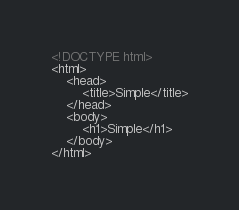<code> <loc_0><loc_0><loc_500><loc_500><_HTML_><!DOCTYPE html>
<html>
    <head>
        <title>Simple</title>
    </head>
    <body>
        <h1>Simple</h1>
    </body>
</html></code> 